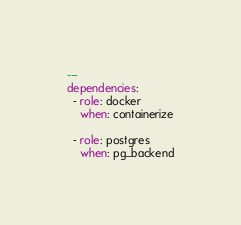<code> <loc_0><loc_0><loc_500><loc_500><_YAML_>---
dependencies:
  - role: docker
    when: containerize

  - role: postgres
    when: pg_backend</code> 